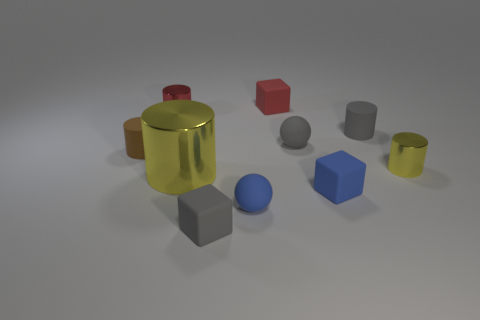How many objects are small blue objects or shiny things that are right of the big cylinder?
Keep it short and to the point. 3. There is a shiny cylinder that is right of the small red rubber cube; how big is it?
Your answer should be compact. Small. Is the number of yellow shiny cylinders that are to the left of the small brown cylinder less than the number of small matte blocks left of the tiny yellow metal thing?
Provide a succinct answer. Yes. There is a small thing that is both in front of the tiny brown object and behind the big yellow thing; what material is it made of?
Your answer should be very brief. Metal. What is the shape of the metal object to the right of the small gray object to the left of the gray rubber ball?
Your answer should be compact. Cylinder. How many red things are either tiny rubber cylinders or shiny cylinders?
Give a very brief answer. 1. There is a large yellow metallic thing; are there any objects to the right of it?
Offer a terse response. Yes. What size is the blue rubber cube?
Provide a succinct answer. Small. What is the size of the other rubber object that is the same shape as the brown thing?
Offer a terse response. Small. What number of blue rubber spheres are left of the rubber sphere that is in front of the small brown rubber cylinder?
Give a very brief answer. 0. 